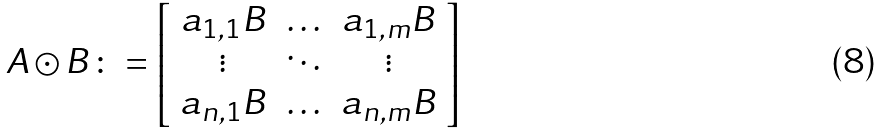Convert formula to latex. <formula><loc_0><loc_0><loc_500><loc_500>A \odot B \colon = \left [ \begin{array} { c c c } a _ { 1 , 1 } B & \hdots & a _ { 1 , m } B \\ \vdots & \ddots & \vdots \\ a _ { n , 1 } B & \hdots & a _ { n , m } B \end{array} \right ]</formula> 